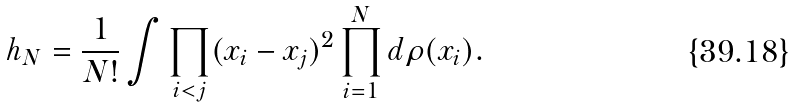<formula> <loc_0><loc_0><loc_500><loc_500>h _ { N } = \frac { 1 } { N ! } \int \prod _ { i < j } ( x _ { i } - x _ { j } ) ^ { 2 } \prod _ { i = 1 } ^ { N } d \rho ( x _ { i } ) .</formula> 